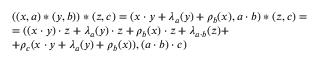<formula> <loc_0><loc_0><loc_500><loc_500>\begin{array} { l } { ( ( x , a ) * ( y , b ) ) * ( z , c ) = ( x \cdot y + \lambda _ { a } ( y ) + \rho _ { b } ( x ) , a \cdot b ) * ( z , c ) = } \\ { = ( ( x \cdot y ) \cdot z + \lambda _ { a } ( y ) \cdot z + \rho _ { b } ( x ) \cdot z + \lambda _ { a \cdot b } ( z ) + } \\ { + \rho _ { c } ( x \cdot y + \lambda _ { a } ( y ) + \rho _ { b } ( x ) ) , ( a \cdot b ) \cdot c ) } \end{array}</formula> 